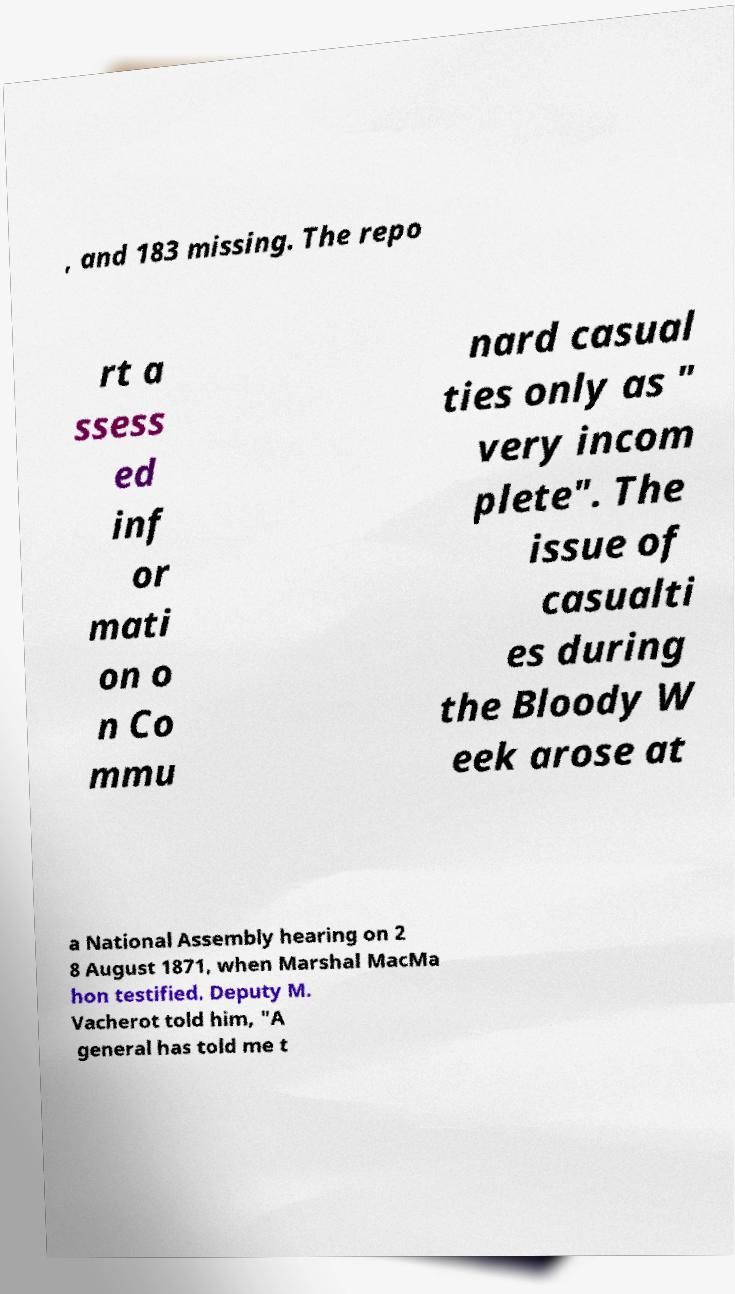Please identify and transcribe the text found in this image. , and 183 missing. The repo rt a ssess ed inf or mati on o n Co mmu nard casual ties only as " very incom plete". The issue of casualti es during the Bloody W eek arose at a National Assembly hearing on 2 8 August 1871, when Marshal MacMa hon testified. Deputy M. Vacherot told him, "A general has told me t 